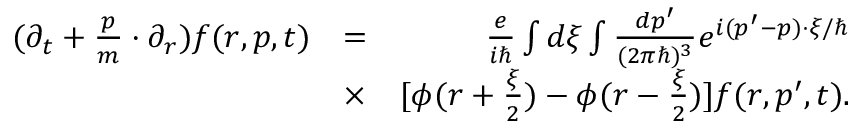<formula> <loc_0><loc_0><loc_500><loc_500>\begin{array} { r l r } { ( \partial _ { t } + \frac { p } { m } \cdot \partial _ { r } ) f ( r , p , t ) } & { = } & { \frac { e } { i } \int d \xi \int \frac { d p ^ { \prime } } { ( 2 \pi \hbar { ) } ^ { 3 } } e ^ { i ( p ^ { \prime } - p ) \cdot \xi / } } \\ & { \times } & { [ \phi ( r + \frac { \xi } { 2 } ) - \phi ( r - \frac { \xi } { 2 } ) ] f ( r , p ^ { \prime } , t ) . } \end{array}</formula> 